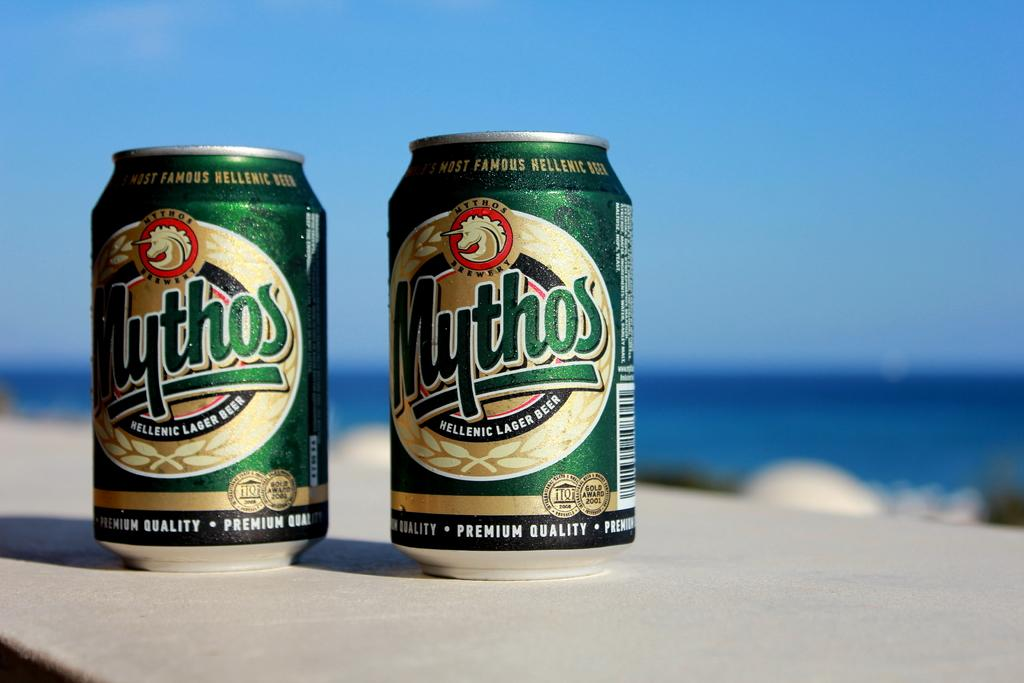How many cans are visible in the image? There are two cans in the image. What can be found on the cans? There is writing on the cans. Where are the cans located in the image? The cans are on a surface. What type of game is being played with the cans in the image? There is no game being played with the cans in the image; they are simply sitting on a surface with writing on them. 